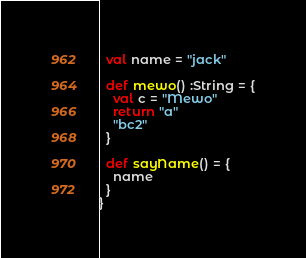Convert code to text. <code><loc_0><loc_0><loc_500><loc_500><_Scala_>  val name = "jack"

  def mewo() :String = {
    val c = "Mewo"
    return "a"
    "bc2"
  }

  def sayName() = {
    name
  }
}
</code> 